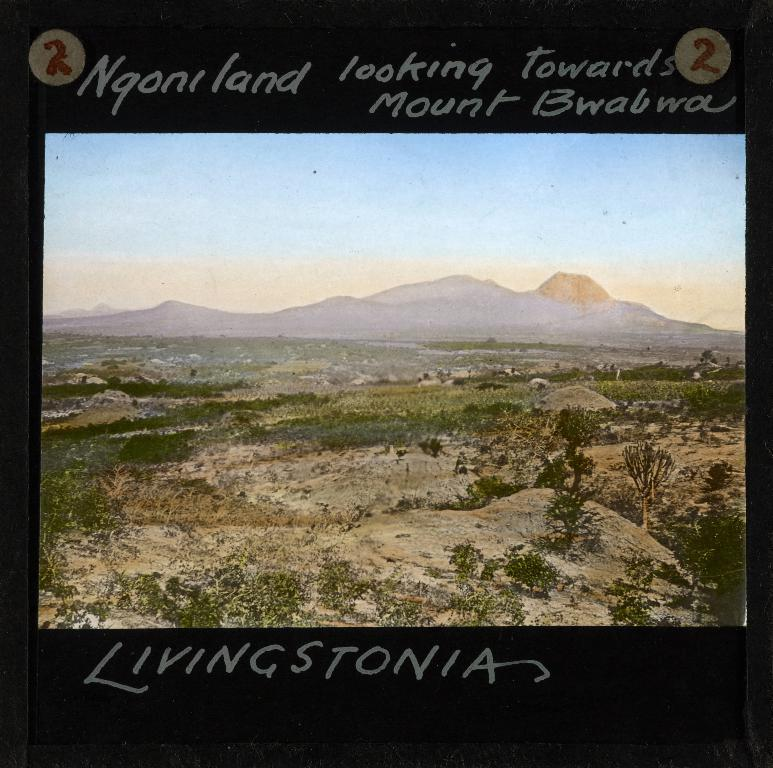<image>
Relay a brief, clear account of the picture shown. Mountain scenery at a distance is shown with a caption that shows it to be "Ngoni land." 